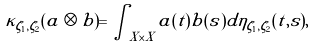Convert formula to latex. <formula><loc_0><loc_0><loc_500><loc_500>\kappa _ { \zeta _ { 1 } , \zeta _ { 2 } } ( a \otimes b ) = \int _ { X \times X } a ( t ) b ( s ) d \eta _ { \zeta _ { 1 } , \zeta _ { 2 } } ( t , s ) ,</formula> 